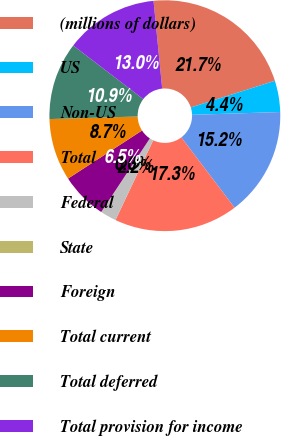<chart> <loc_0><loc_0><loc_500><loc_500><pie_chart><fcel>(millions of dollars)<fcel>US<fcel>Non-US<fcel>Total<fcel>Federal<fcel>State<fcel>Foreign<fcel>Total current<fcel>Total deferred<fcel>Total provision for income<nl><fcel>21.68%<fcel>4.38%<fcel>15.19%<fcel>17.35%<fcel>2.21%<fcel>0.05%<fcel>6.54%<fcel>8.7%<fcel>10.87%<fcel>13.03%<nl></chart> 